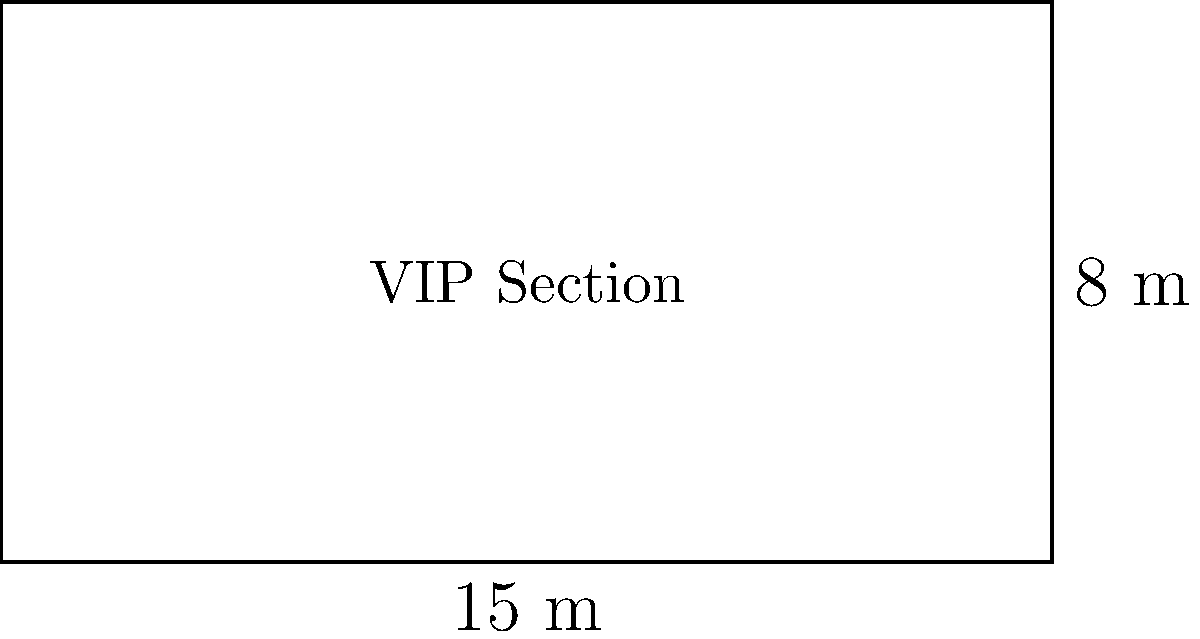At the Public Enemy concert you missed, there was a special VIP section. The rectangular VIP area measured 15 meters in length and 8 meters in width. What was the total area of the VIP section in square meters? To find the area of a rectangular shape, we need to multiply its length by its width. Let's follow these steps:

1. Identify the given dimensions:
   - Length = 15 meters
   - Width = 8 meters

2. Apply the formula for the area of a rectangle:
   $$ A = l \times w $$
   Where:
   $A$ = Area
   $l$ = Length
   $w$ = Width

3. Substitute the values into the formula:
   $$ A = 15 \text{ m} \times 8 \text{ m} $$

4. Perform the multiplication:
   $$ A = 120 \text{ m}^2 $$

Therefore, the total area of the VIP section is 120 square meters.
Answer: 120 m² 